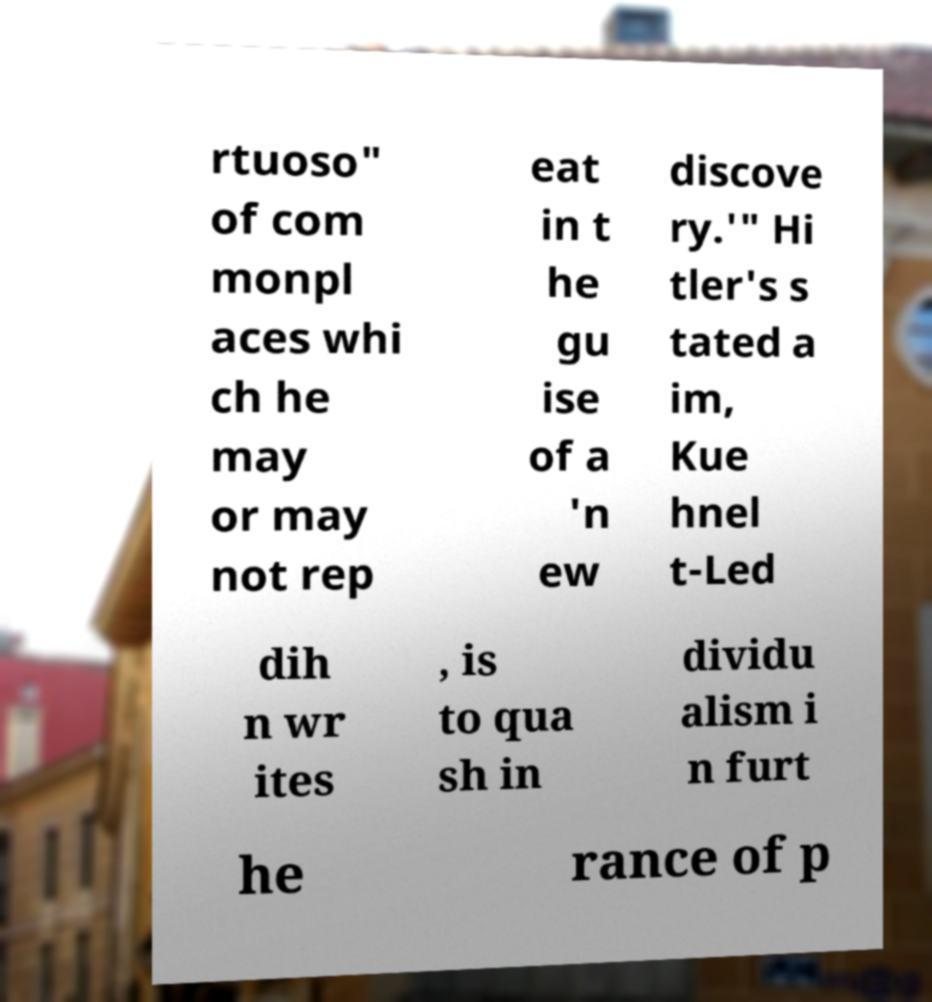Could you assist in decoding the text presented in this image and type it out clearly? rtuoso" of com monpl aces whi ch he may or may not rep eat in t he gu ise of a 'n ew discove ry.'" Hi tler's s tated a im, Kue hnel t-Led dih n wr ites , is to qua sh in dividu alism i n furt he rance of p 